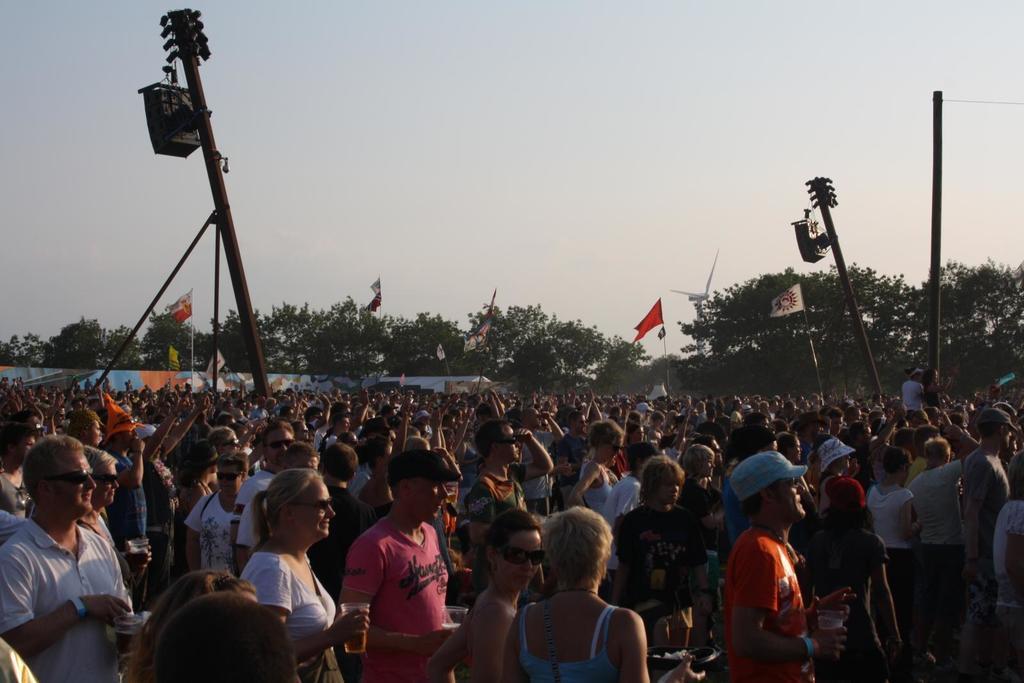Could you give a brief overview of what you see in this image? In this image we can see group of people, poles, flags, trees, and objects. In the background there is sky. 